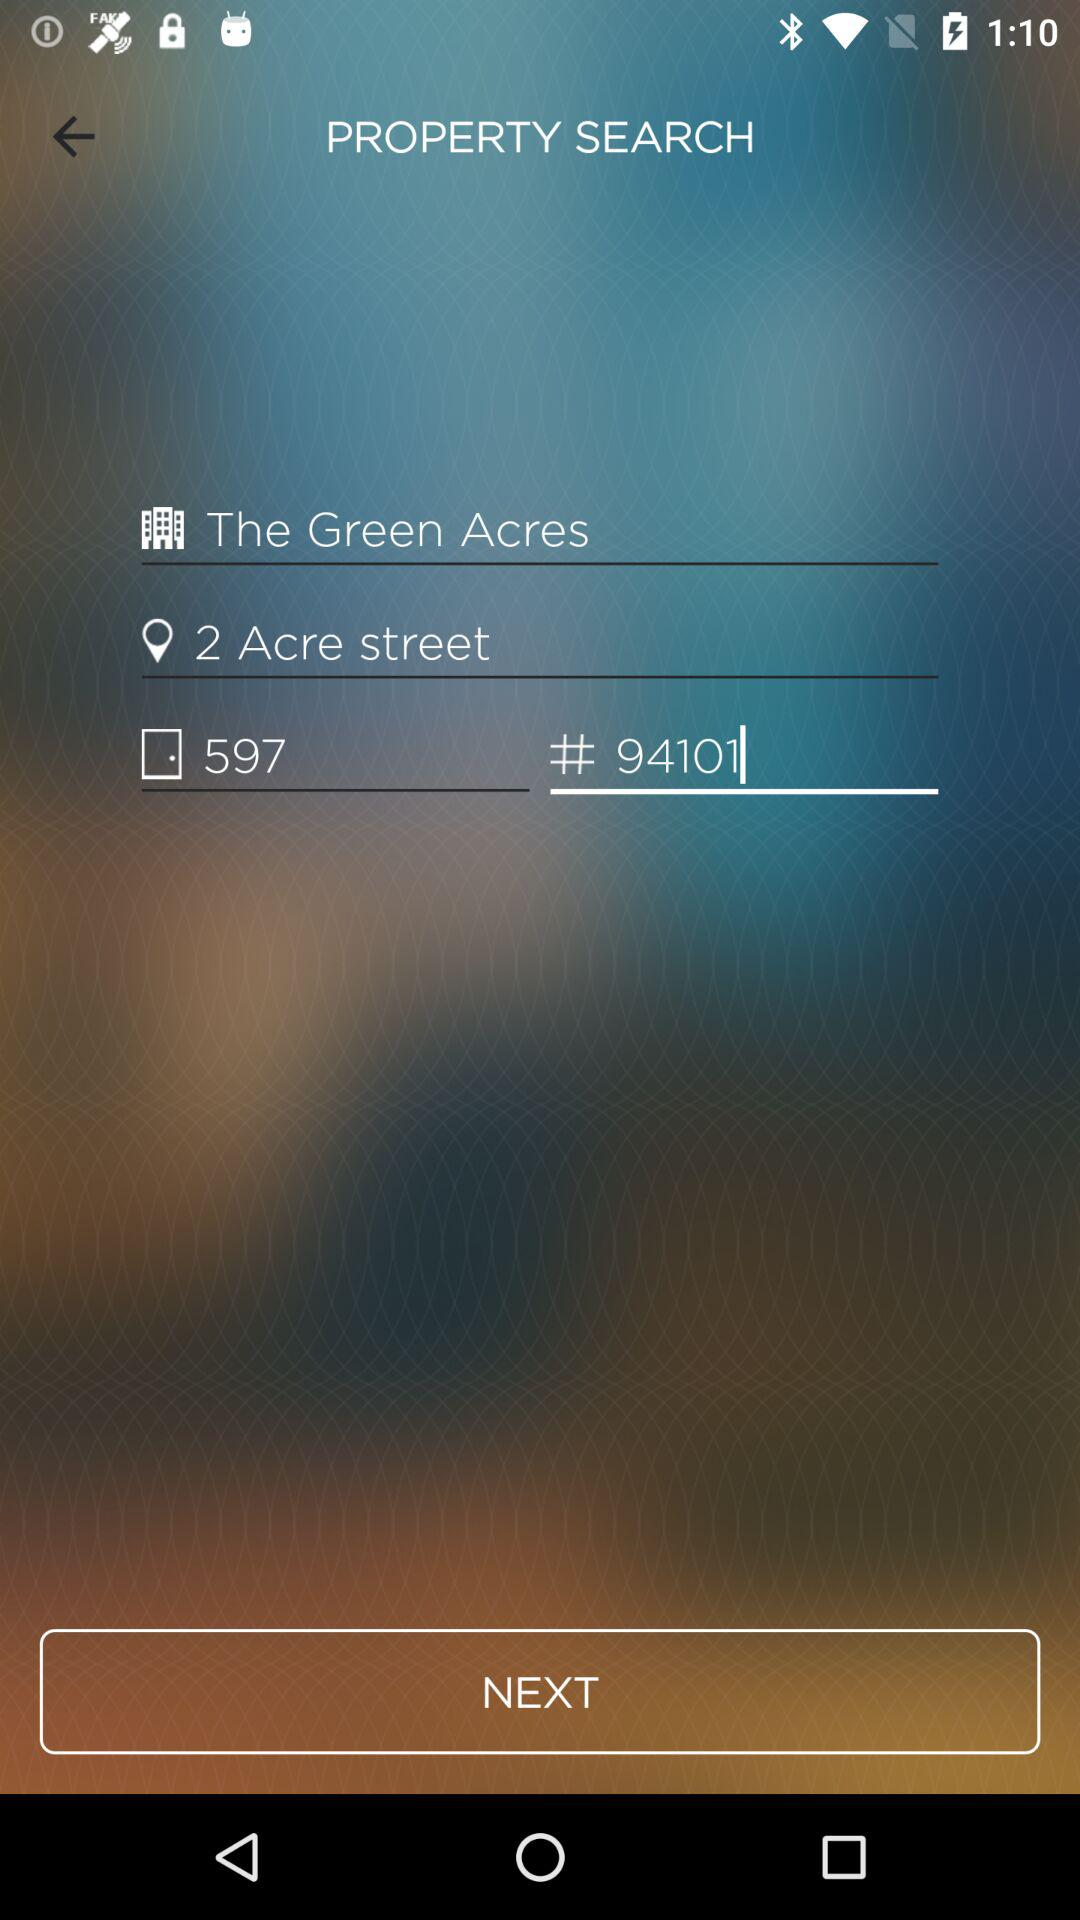What is the name of the property shown on the screen? The name of the property is "The Green Acres". 